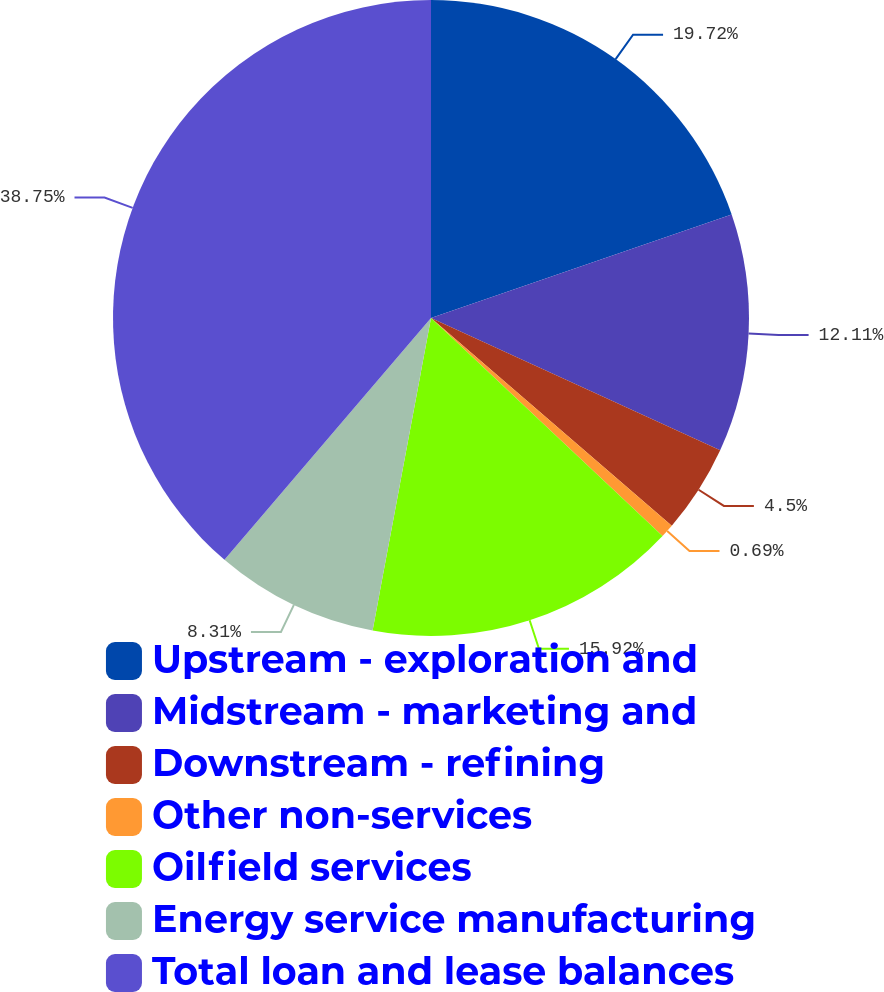<chart> <loc_0><loc_0><loc_500><loc_500><pie_chart><fcel>Upstream - exploration and<fcel>Midstream - marketing and<fcel>Downstream - refining<fcel>Other non-services<fcel>Oilfield services<fcel>Energy service manufacturing<fcel>Total loan and lease balances<nl><fcel>19.72%<fcel>12.11%<fcel>4.5%<fcel>0.69%<fcel>15.92%<fcel>8.31%<fcel>38.75%<nl></chart> 